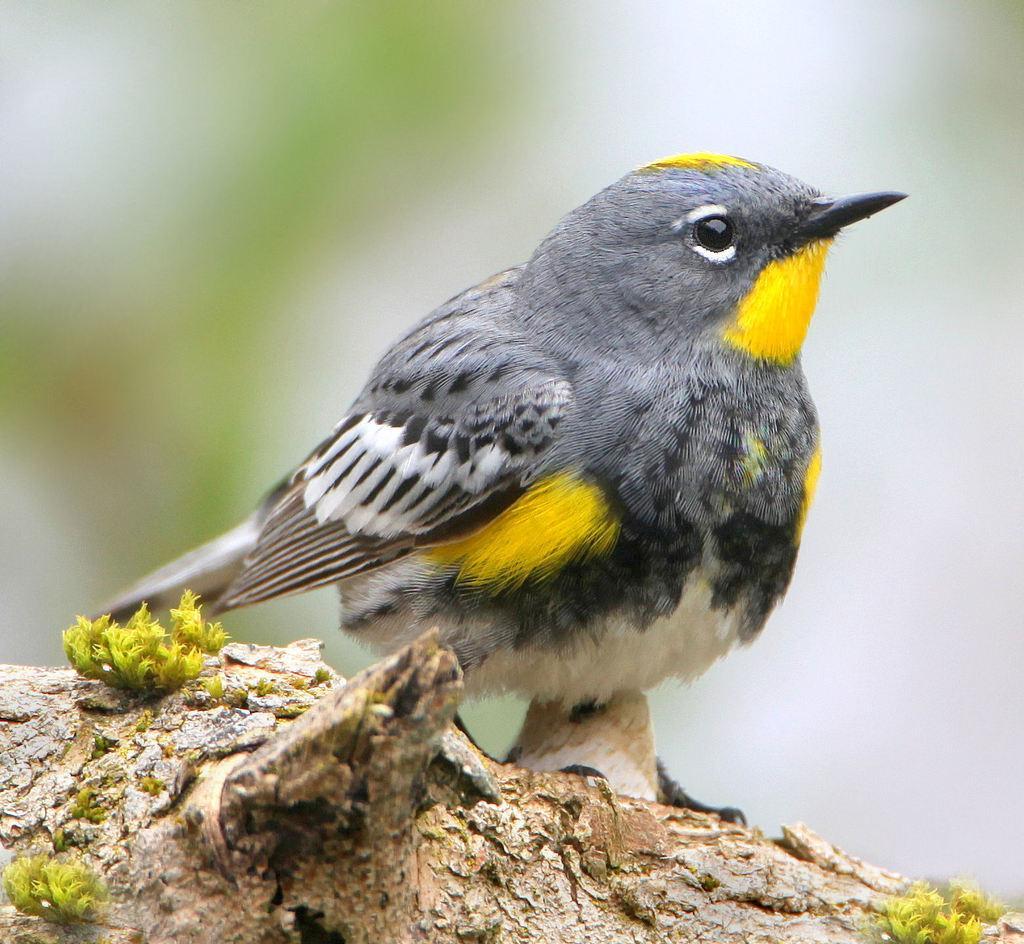Please provide a concise description of this image. In this picture we can see a bird on the branch. Behind the bird there is the blurred background. 